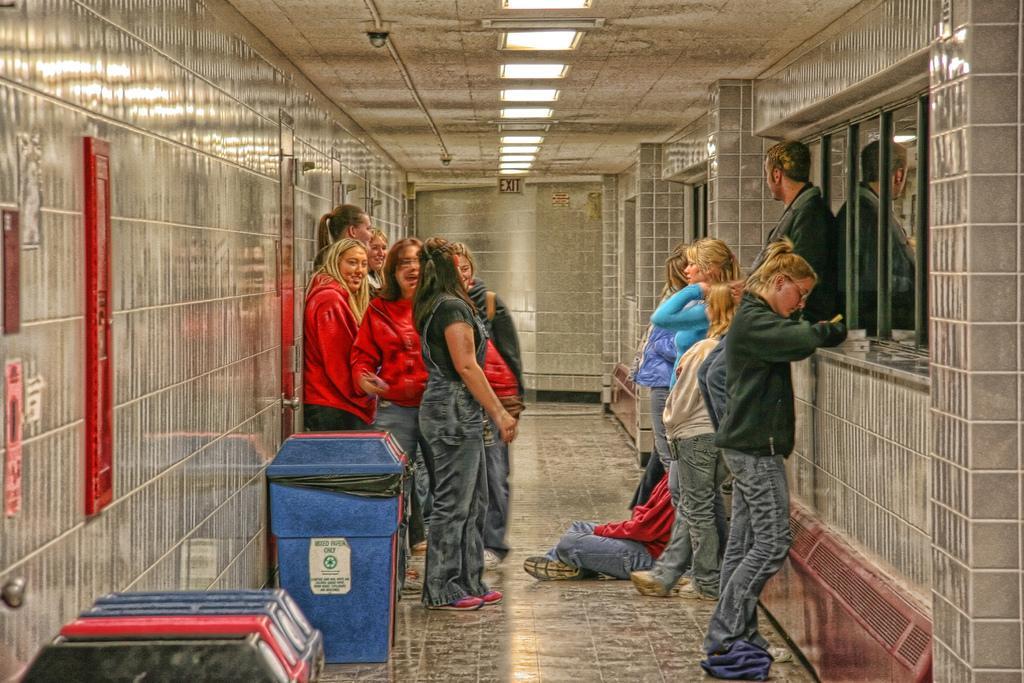Describe this image in one or two sentences. In this image we can see people standing and there is a person sitting on the floor. On the left there are bins. In the background there is a wall and we can see lights. 